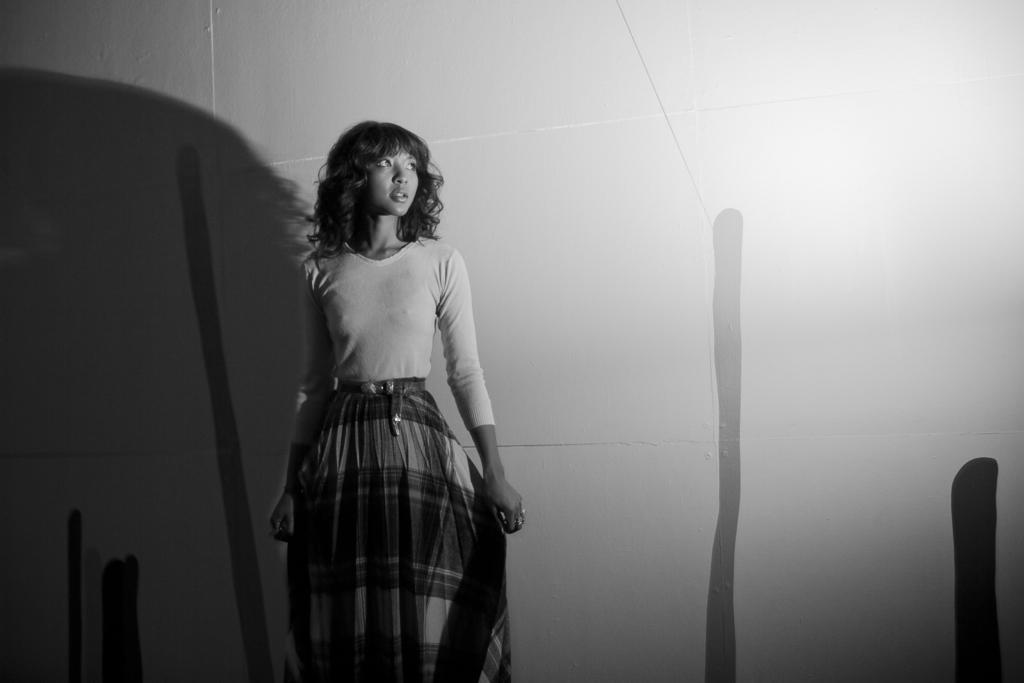What is the color scheme of the image? The image is black and white. What can be seen in the background of the image? There is a wall visible in the background of the image. Who is present in the image? There is a woman in the image. What is the woman wearing? The woman is wearing a dress. What is the woman doing in the image? The woman is giving a pose. What type of food is the woman holding in the image? There is no food present in the image; the woman is not holding any food. How many nails can be seen in the image? There are no nails visible in the image. 